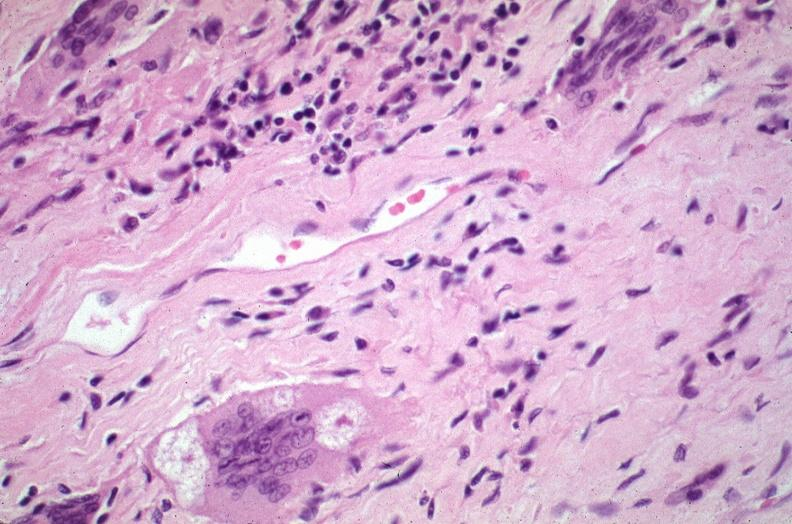does this image show lung, sarcoidosis, multinucleated giant cells with asteroid bodies?
Answer the question using a single word or phrase. Yes 